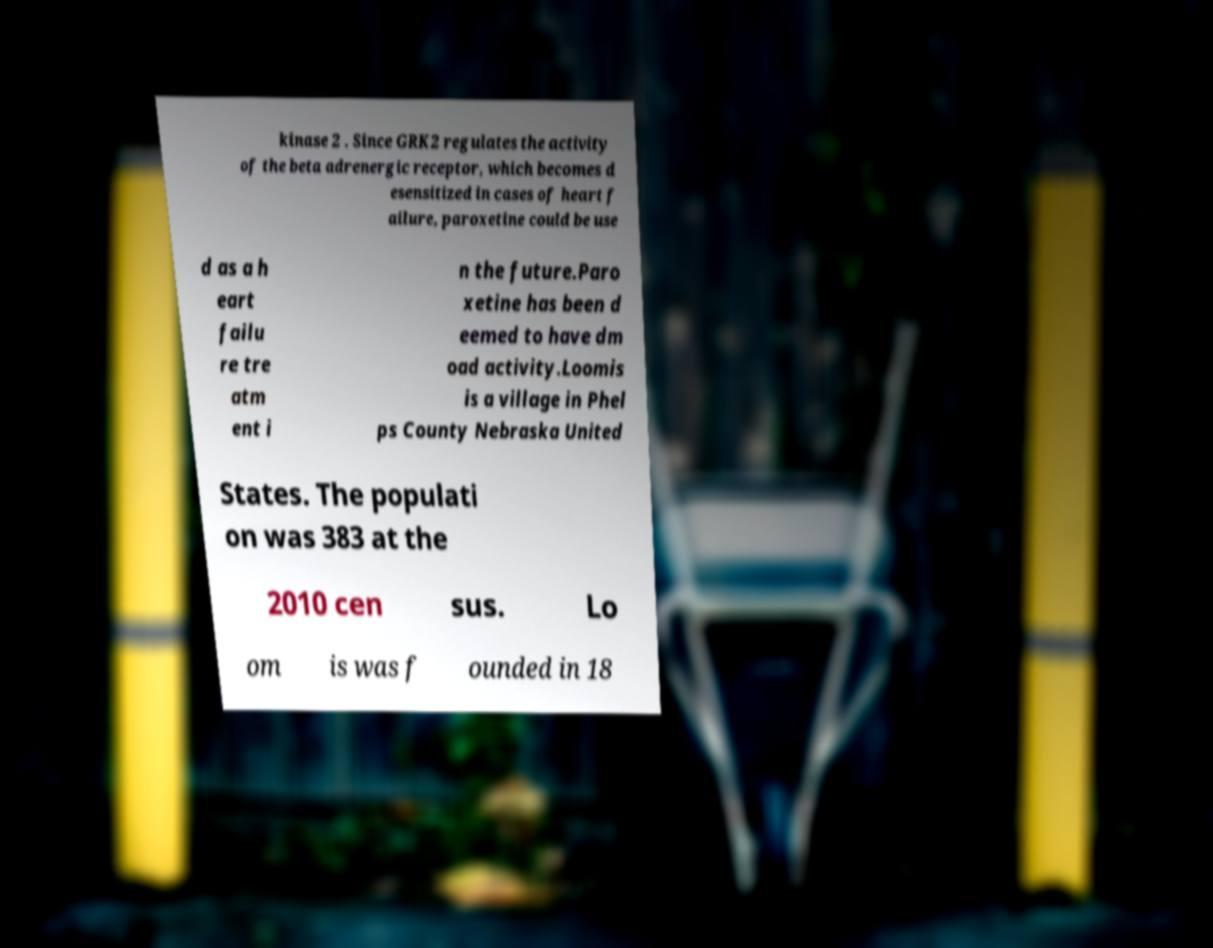For documentation purposes, I need the text within this image transcribed. Could you provide that? kinase 2 . Since GRK2 regulates the activity of the beta adrenergic receptor, which becomes d esensitized in cases of heart f ailure, paroxetine could be use d as a h eart failu re tre atm ent i n the future.Paro xetine has been d eemed to have dm oad activity.Loomis is a village in Phel ps County Nebraska United States. The populati on was 383 at the 2010 cen sus. Lo om is was f ounded in 18 